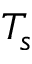Convert formula to latex. <formula><loc_0><loc_0><loc_500><loc_500>T _ { s }</formula> 